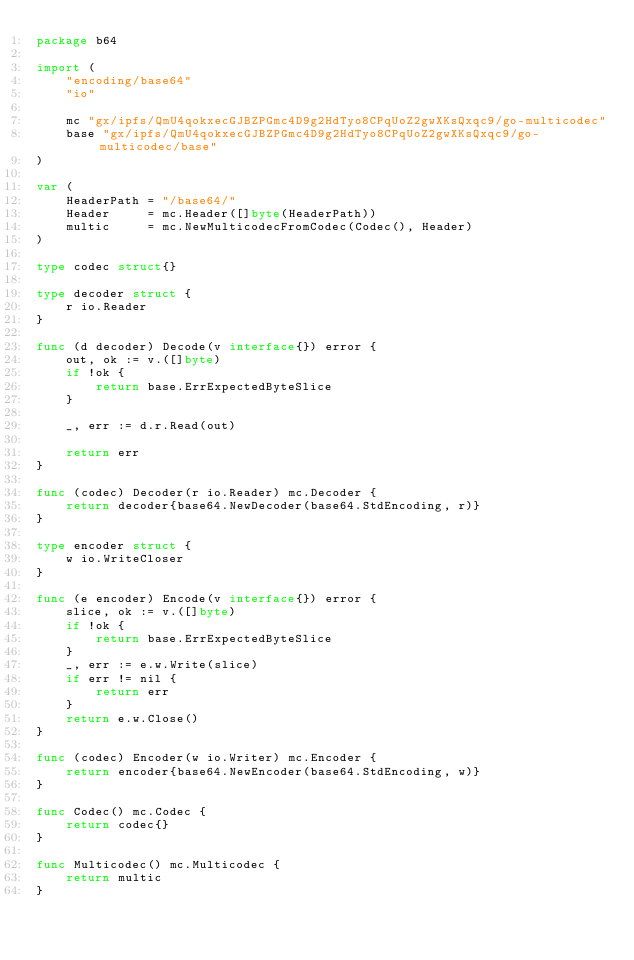Convert code to text. <code><loc_0><loc_0><loc_500><loc_500><_Go_>package b64

import (
	"encoding/base64"
	"io"

	mc "gx/ipfs/QmU4qokxecGJBZPGmc4D9g2HdTyo8CPqUoZ2gwXKsQxqc9/go-multicodec"
	base "gx/ipfs/QmU4qokxecGJBZPGmc4D9g2HdTyo8CPqUoZ2gwXKsQxqc9/go-multicodec/base"
)

var (
	HeaderPath = "/base64/"
	Header     = mc.Header([]byte(HeaderPath))
	multic     = mc.NewMulticodecFromCodec(Codec(), Header)
)

type codec struct{}

type decoder struct {
	r io.Reader
}

func (d decoder) Decode(v interface{}) error {
	out, ok := v.([]byte)
	if !ok {
		return base.ErrExpectedByteSlice
	}

	_, err := d.r.Read(out)

	return err
}

func (codec) Decoder(r io.Reader) mc.Decoder {
	return decoder{base64.NewDecoder(base64.StdEncoding, r)}
}

type encoder struct {
	w io.WriteCloser
}

func (e encoder) Encode(v interface{}) error {
	slice, ok := v.([]byte)
	if !ok {
		return base.ErrExpectedByteSlice
	}
	_, err := e.w.Write(slice)
	if err != nil {
		return err
	}
	return e.w.Close()
}

func (codec) Encoder(w io.Writer) mc.Encoder {
	return encoder{base64.NewEncoder(base64.StdEncoding, w)}
}

func Codec() mc.Codec {
	return codec{}
}

func Multicodec() mc.Multicodec {
	return multic
}
</code> 